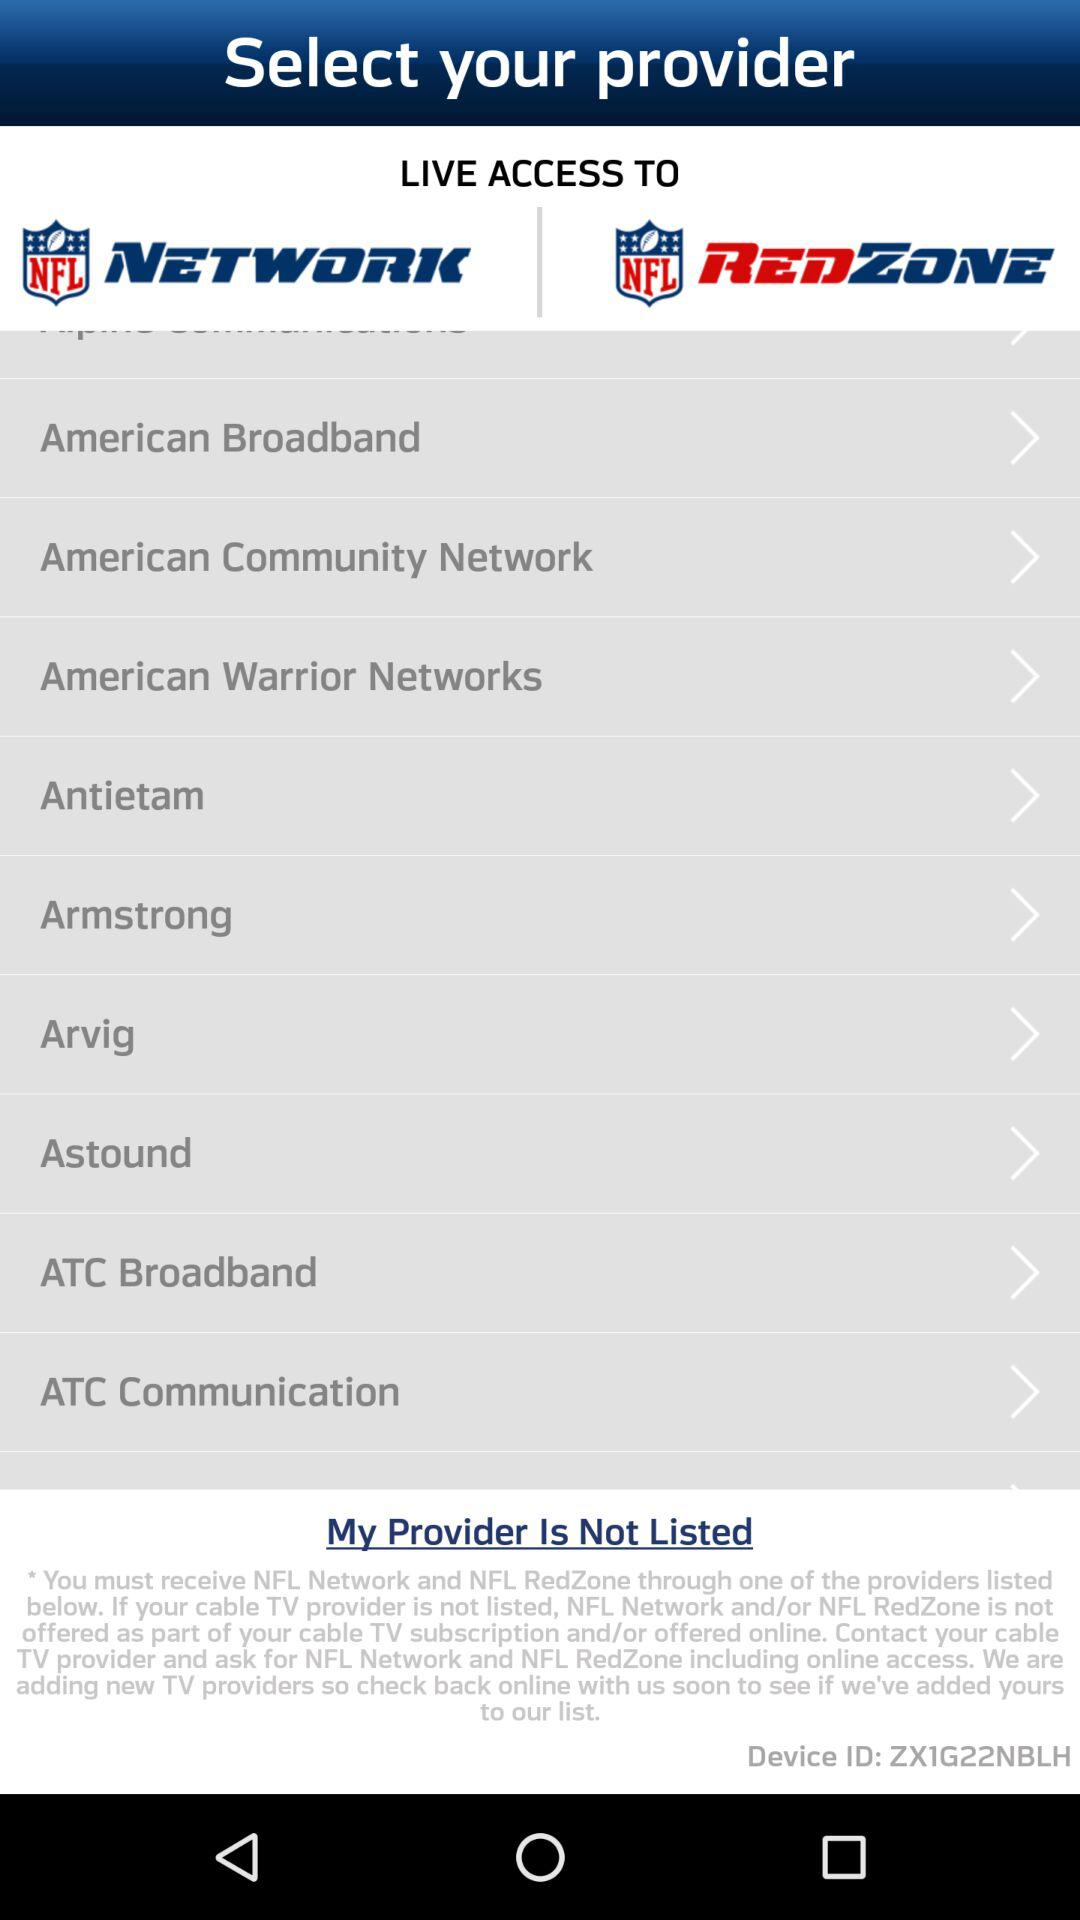Which broadband provider provides live access? The broadband providers that provide live access are "American Broadband", "American Community Network", "American Warrior Networks", "Antietam", "Armstrong", "Arvig", "Astound", "ATC Broadband" and "ATC Communication". 